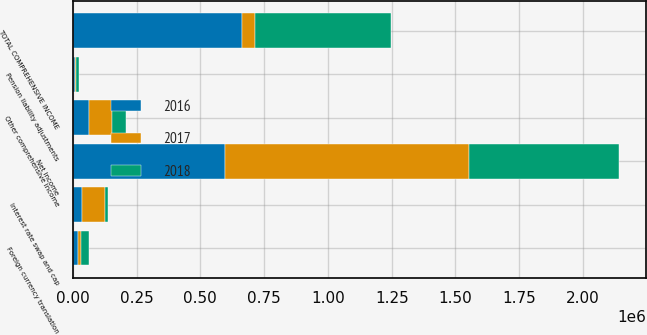Convert chart. <chart><loc_0><loc_0><loc_500><loc_500><stacked_bar_chart><ecel><fcel>Net income<fcel>Foreign currency translation<fcel>Interest rate swap and cap<fcel>Pension liability adjustments<fcel>Other comprehensive income<fcel>TOTAL COMPREHENSIVE INCOME<nl><fcel>2017<fcel>957062<fcel>10253<fcel>93860<fcel>5636<fcel>89243<fcel>53778<nl><fcel>2016<fcel>596887<fcel>22241<fcel>34471<fcel>7932<fcel>64644<fcel>661531<nl><fcel>2018<fcel>586414<fcel>31846<fcel>9648<fcel>12284<fcel>53778<fcel>532636<nl></chart> 